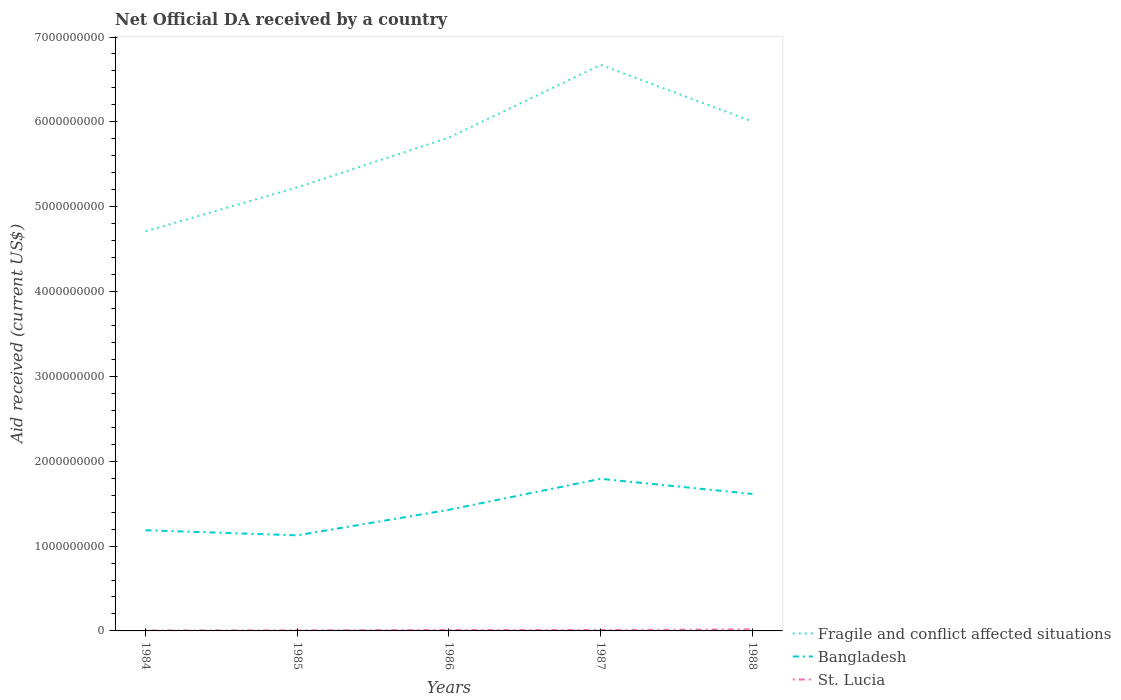How many different coloured lines are there?
Provide a short and direct response. 3. Is the number of lines equal to the number of legend labels?
Ensure brevity in your answer.  Yes. Across all years, what is the maximum net official development assistance aid received in St. Lucia?
Your response must be concise. 5.65e+06. In which year was the net official development assistance aid received in Bangladesh maximum?
Make the answer very short. 1985. What is the total net official development assistance aid received in Bangladesh in the graph?
Offer a terse response. -3.65e+08. What is the difference between the highest and the second highest net official development assistance aid received in St. Lucia?
Your answer should be very brief. 1.23e+07. Is the net official development assistance aid received in Fragile and conflict affected situations strictly greater than the net official development assistance aid received in Bangladesh over the years?
Provide a succinct answer. No. What is the difference between two consecutive major ticks on the Y-axis?
Offer a terse response. 1.00e+09. Does the graph contain grids?
Keep it short and to the point. No. Where does the legend appear in the graph?
Offer a terse response. Bottom right. How many legend labels are there?
Make the answer very short. 3. What is the title of the graph?
Keep it short and to the point. Net Official DA received by a country. What is the label or title of the Y-axis?
Your response must be concise. Aid received (current US$). What is the Aid received (current US$) of Fragile and conflict affected situations in 1984?
Provide a succinct answer. 4.71e+09. What is the Aid received (current US$) in Bangladesh in 1984?
Your answer should be very brief. 1.19e+09. What is the Aid received (current US$) of St. Lucia in 1984?
Make the answer very short. 5.65e+06. What is the Aid received (current US$) in Fragile and conflict affected situations in 1985?
Your answer should be very brief. 5.23e+09. What is the Aid received (current US$) of Bangladesh in 1985?
Your answer should be compact. 1.13e+09. What is the Aid received (current US$) of St. Lucia in 1985?
Your answer should be compact. 6.98e+06. What is the Aid received (current US$) in Fragile and conflict affected situations in 1986?
Provide a succinct answer. 5.81e+09. What is the Aid received (current US$) in Bangladesh in 1986?
Offer a very short reply. 1.43e+09. What is the Aid received (current US$) of St. Lucia in 1986?
Offer a terse response. 1.17e+07. What is the Aid received (current US$) of Fragile and conflict affected situations in 1987?
Provide a short and direct response. 6.67e+09. What is the Aid received (current US$) in Bangladesh in 1987?
Offer a terse response. 1.79e+09. What is the Aid received (current US$) in St. Lucia in 1987?
Give a very brief answer. 1.07e+07. What is the Aid received (current US$) of Fragile and conflict affected situations in 1988?
Offer a very short reply. 6.00e+09. What is the Aid received (current US$) of Bangladesh in 1988?
Offer a very short reply. 1.61e+09. What is the Aid received (current US$) in St. Lucia in 1988?
Your response must be concise. 1.80e+07. Across all years, what is the maximum Aid received (current US$) in Fragile and conflict affected situations?
Ensure brevity in your answer.  6.67e+09. Across all years, what is the maximum Aid received (current US$) in Bangladesh?
Ensure brevity in your answer.  1.79e+09. Across all years, what is the maximum Aid received (current US$) of St. Lucia?
Offer a very short reply. 1.80e+07. Across all years, what is the minimum Aid received (current US$) in Fragile and conflict affected situations?
Provide a short and direct response. 4.71e+09. Across all years, what is the minimum Aid received (current US$) in Bangladesh?
Provide a succinct answer. 1.13e+09. Across all years, what is the minimum Aid received (current US$) in St. Lucia?
Your answer should be very brief. 5.65e+06. What is the total Aid received (current US$) of Fragile and conflict affected situations in the graph?
Your answer should be very brief. 2.84e+1. What is the total Aid received (current US$) in Bangladesh in the graph?
Your answer should be compact. 7.15e+09. What is the total Aid received (current US$) in St. Lucia in the graph?
Ensure brevity in your answer.  5.30e+07. What is the difference between the Aid received (current US$) of Fragile and conflict affected situations in 1984 and that in 1985?
Keep it short and to the point. -5.18e+08. What is the difference between the Aid received (current US$) in Bangladesh in 1984 and that in 1985?
Make the answer very short. 6.03e+07. What is the difference between the Aid received (current US$) of St. Lucia in 1984 and that in 1985?
Give a very brief answer. -1.33e+06. What is the difference between the Aid received (current US$) in Fragile and conflict affected situations in 1984 and that in 1986?
Offer a terse response. -1.11e+09. What is the difference between the Aid received (current US$) in Bangladesh in 1984 and that in 1986?
Offer a terse response. -2.41e+08. What is the difference between the Aid received (current US$) in St. Lucia in 1984 and that in 1986?
Provide a short and direct response. -6.01e+06. What is the difference between the Aid received (current US$) of Fragile and conflict affected situations in 1984 and that in 1987?
Ensure brevity in your answer.  -1.96e+09. What is the difference between the Aid received (current US$) in Bangladesh in 1984 and that in 1987?
Provide a short and direct response. -6.06e+08. What is the difference between the Aid received (current US$) of St. Lucia in 1984 and that in 1987?
Ensure brevity in your answer.  -5.06e+06. What is the difference between the Aid received (current US$) in Fragile and conflict affected situations in 1984 and that in 1988?
Offer a terse response. -1.29e+09. What is the difference between the Aid received (current US$) in Bangladesh in 1984 and that in 1988?
Your response must be concise. -4.28e+08. What is the difference between the Aid received (current US$) of St. Lucia in 1984 and that in 1988?
Provide a short and direct response. -1.23e+07. What is the difference between the Aid received (current US$) in Fragile and conflict affected situations in 1985 and that in 1986?
Offer a very short reply. -5.87e+08. What is the difference between the Aid received (current US$) in Bangladesh in 1985 and that in 1986?
Your answer should be compact. -3.02e+08. What is the difference between the Aid received (current US$) of St. Lucia in 1985 and that in 1986?
Provide a short and direct response. -4.68e+06. What is the difference between the Aid received (current US$) of Fragile and conflict affected situations in 1985 and that in 1987?
Provide a short and direct response. -1.44e+09. What is the difference between the Aid received (current US$) of Bangladesh in 1985 and that in 1987?
Give a very brief answer. -6.66e+08. What is the difference between the Aid received (current US$) of St. Lucia in 1985 and that in 1987?
Your response must be concise. -3.73e+06. What is the difference between the Aid received (current US$) of Fragile and conflict affected situations in 1985 and that in 1988?
Provide a succinct answer. -7.76e+08. What is the difference between the Aid received (current US$) of Bangladesh in 1985 and that in 1988?
Provide a short and direct response. -4.88e+08. What is the difference between the Aid received (current US$) of St. Lucia in 1985 and that in 1988?
Provide a short and direct response. -1.10e+07. What is the difference between the Aid received (current US$) of Fragile and conflict affected situations in 1986 and that in 1987?
Offer a very short reply. -8.57e+08. What is the difference between the Aid received (current US$) of Bangladesh in 1986 and that in 1987?
Make the answer very short. -3.65e+08. What is the difference between the Aid received (current US$) of St. Lucia in 1986 and that in 1987?
Your answer should be very brief. 9.50e+05. What is the difference between the Aid received (current US$) of Fragile and conflict affected situations in 1986 and that in 1988?
Offer a very short reply. -1.89e+08. What is the difference between the Aid received (current US$) in Bangladesh in 1986 and that in 1988?
Provide a succinct answer. -1.86e+08. What is the difference between the Aid received (current US$) of St. Lucia in 1986 and that in 1988?
Your answer should be very brief. -6.30e+06. What is the difference between the Aid received (current US$) of Fragile and conflict affected situations in 1987 and that in 1988?
Your answer should be very brief. 6.68e+08. What is the difference between the Aid received (current US$) of Bangladesh in 1987 and that in 1988?
Offer a very short reply. 1.78e+08. What is the difference between the Aid received (current US$) of St. Lucia in 1987 and that in 1988?
Give a very brief answer. -7.25e+06. What is the difference between the Aid received (current US$) in Fragile and conflict affected situations in 1984 and the Aid received (current US$) in Bangladesh in 1985?
Offer a terse response. 3.58e+09. What is the difference between the Aid received (current US$) of Fragile and conflict affected situations in 1984 and the Aid received (current US$) of St. Lucia in 1985?
Ensure brevity in your answer.  4.70e+09. What is the difference between the Aid received (current US$) in Bangladesh in 1984 and the Aid received (current US$) in St. Lucia in 1985?
Your response must be concise. 1.18e+09. What is the difference between the Aid received (current US$) in Fragile and conflict affected situations in 1984 and the Aid received (current US$) in Bangladesh in 1986?
Your answer should be very brief. 3.28e+09. What is the difference between the Aid received (current US$) of Fragile and conflict affected situations in 1984 and the Aid received (current US$) of St. Lucia in 1986?
Offer a very short reply. 4.70e+09. What is the difference between the Aid received (current US$) of Bangladesh in 1984 and the Aid received (current US$) of St. Lucia in 1986?
Your answer should be very brief. 1.18e+09. What is the difference between the Aid received (current US$) in Fragile and conflict affected situations in 1984 and the Aid received (current US$) in Bangladesh in 1987?
Provide a succinct answer. 2.92e+09. What is the difference between the Aid received (current US$) in Fragile and conflict affected situations in 1984 and the Aid received (current US$) in St. Lucia in 1987?
Offer a terse response. 4.70e+09. What is the difference between the Aid received (current US$) of Bangladesh in 1984 and the Aid received (current US$) of St. Lucia in 1987?
Your response must be concise. 1.18e+09. What is the difference between the Aid received (current US$) in Fragile and conflict affected situations in 1984 and the Aid received (current US$) in Bangladesh in 1988?
Give a very brief answer. 3.10e+09. What is the difference between the Aid received (current US$) in Fragile and conflict affected situations in 1984 and the Aid received (current US$) in St. Lucia in 1988?
Your answer should be compact. 4.69e+09. What is the difference between the Aid received (current US$) in Bangladesh in 1984 and the Aid received (current US$) in St. Lucia in 1988?
Provide a short and direct response. 1.17e+09. What is the difference between the Aid received (current US$) in Fragile and conflict affected situations in 1985 and the Aid received (current US$) in Bangladesh in 1986?
Make the answer very short. 3.80e+09. What is the difference between the Aid received (current US$) of Fragile and conflict affected situations in 1985 and the Aid received (current US$) of St. Lucia in 1986?
Provide a succinct answer. 5.22e+09. What is the difference between the Aid received (current US$) of Bangladesh in 1985 and the Aid received (current US$) of St. Lucia in 1986?
Make the answer very short. 1.11e+09. What is the difference between the Aid received (current US$) in Fragile and conflict affected situations in 1985 and the Aid received (current US$) in Bangladesh in 1987?
Make the answer very short. 3.44e+09. What is the difference between the Aid received (current US$) of Fragile and conflict affected situations in 1985 and the Aid received (current US$) of St. Lucia in 1987?
Provide a succinct answer. 5.22e+09. What is the difference between the Aid received (current US$) of Bangladesh in 1985 and the Aid received (current US$) of St. Lucia in 1987?
Your answer should be very brief. 1.12e+09. What is the difference between the Aid received (current US$) in Fragile and conflict affected situations in 1985 and the Aid received (current US$) in Bangladesh in 1988?
Your response must be concise. 3.61e+09. What is the difference between the Aid received (current US$) in Fragile and conflict affected situations in 1985 and the Aid received (current US$) in St. Lucia in 1988?
Provide a succinct answer. 5.21e+09. What is the difference between the Aid received (current US$) in Bangladesh in 1985 and the Aid received (current US$) in St. Lucia in 1988?
Ensure brevity in your answer.  1.11e+09. What is the difference between the Aid received (current US$) of Fragile and conflict affected situations in 1986 and the Aid received (current US$) of Bangladesh in 1987?
Your answer should be compact. 4.02e+09. What is the difference between the Aid received (current US$) of Fragile and conflict affected situations in 1986 and the Aid received (current US$) of St. Lucia in 1987?
Your answer should be compact. 5.80e+09. What is the difference between the Aid received (current US$) in Bangladesh in 1986 and the Aid received (current US$) in St. Lucia in 1987?
Provide a short and direct response. 1.42e+09. What is the difference between the Aid received (current US$) in Fragile and conflict affected situations in 1986 and the Aid received (current US$) in Bangladesh in 1988?
Your answer should be compact. 4.20e+09. What is the difference between the Aid received (current US$) of Fragile and conflict affected situations in 1986 and the Aid received (current US$) of St. Lucia in 1988?
Your answer should be very brief. 5.80e+09. What is the difference between the Aid received (current US$) of Bangladesh in 1986 and the Aid received (current US$) of St. Lucia in 1988?
Make the answer very short. 1.41e+09. What is the difference between the Aid received (current US$) in Fragile and conflict affected situations in 1987 and the Aid received (current US$) in Bangladesh in 1988?
Provide a short and direct response. 5.06e+09. What is the difference between the Aid received (current US$) in Fragile and conflict affected situations in 1987 and the Aid received (current US$) in St. Lucia in 1988?
Your response must be concise. 6.65e+09. What is the difference between the Aid received (current US$) in Bangladesh in 1987 and the Aid received (current US$) in St. Lucia in 1988?
Your answer should be compact. 1.77e+09. What is the average Aid received (current US$) in Fragile and conflict affected situations per year?
Make the answer very short. 5.69e+09. What is the average Aid received (current US$) of Bangladesh per year?
Your answer should be very brief. 1.43e+09. What is the average Aid received (current US$) in St. Lucia per year?
Provide a succinct answer. 1.06e+07. In the year 1984, what is the difference between the Aid received (current US$) in Fragile and conflict affected situations and Aid received (current US$) in Bangladesh?
Provide a short and direct response. 3.52e+09. In the year 1984, what is the difference between the Aid received (current US$) in Fragile and conflict affected situations and Aid received (current US$) in St. Lucia?
Make the answer very short. 4.70e+09. In the year 1984, what is the difference between the Aid received (current US$) in Bangladesh and Aid received (current US$) in St. Lucia?
Provide a succinct answer. 1.18e+09. In the year 1985, what is the difference between the Aid received (current US$) in Fragile and conflict affected situations and Aid received (current US$) in Bangladesh?
Offer a very short reply. 4.10e+09. In the year 1985, what is the difference between the Aid received (current US$) in Fragile and conflict affected situations and Aid received (current US$) in St. Lucia?
Offer a terse response. 5.22e+09. In the year 1985, what is the difference between the Aid received (current US$) of Bangladesh and Aid received (current US$) of St. Lucia?
Ensure brevity in your answer.  1.12e+09. In the year 1986, what is the difference between the Aid received (current US$) of Fragile and conflict affected situations and Aid received (current US$) of Bangladesh?
Ensure brevity in your answer.  4.39e+09. In the year 1986, what is the difference between the Aid received (current US$) of Fragile and conflict affected situations and Aid received (current US$) of St. Lucia?
Your answer should be compact. 5.80e+09. In the year 1986, what is the difference between the Aid received (current US$) in Bangladesh and Aid received (current US$) in St. Lucia?
Make the answer very short. 1.42e+09. In the year 1987, what is the difference between the Aid received (current US$) in Fragile and conflict affected situations and Aid received (current US$) in Bangladesh?
Offer a very short reply. 4.88e+09. In the year 1987, what is the difference between the Aid received (current US$) in Fragile and conflict affected situations and Aid received (current US$) in St. Lucia?
Provide a short and direct response. 6.66e+09. In the year 1987, what is the difference between the Aid received (current US$) of Bangladesh and Aid received (current US$) of St. Lucia?
Offer a very short reply. 1.78e+09. In the year 1988, what is the difference between the Aid received (current US$) in Fragile and conflict affected situations and Aid received (current US$) in Bangladesh?
Make the answer very short. 4.39e+09. In the year 1988, what is the difference between the Aid received (current US$) of Fragile and conflict affected situations and Aid received (current US$) of St. Lucia?
Your answer should be very brief. 5.99e+09. In the year 1988, what is the difference between the Aid received (current US$) of Bangladesh and Aid received (current US$) of St. Lucia?
Your answer should be compact. 1.60e+09. What is the ratio of the Aid received (current US$) in Fragile and conflict affected situations in 1984 to that in 1985?
Offer a terse response. 0.9. What is the ratio of the Aid received (current US$) of Bangladesh in 1984 to that in 1985?
Give a very brief answer. 1.05. What is the ratio of the Aid received (current US$) in St. Lucia in 1984 to that in 1985?
Ensure brevity in your answer.  0.81. What is the ratio of the Aid received (current US$) of Fragile and conflict affected situations in 1984 to that in 1986?
Ensure brevity in your answer.  0.81. What is the ratio of the Aid received (current US$) of Bangladesh in 1984 to that in 1986?
Offer a very short reply. 0.83. What is the ratio of the Aid received (current US$) of St. Lucia in 1984 to that in 1986?
Offer a terse response. 0.48. What is the ratio of the Aid received (current US$) in Fragile and conflict affected situations in 1984 to that in 1987?
Your response must be concise. 0.71. What is the ratio of the Aid received (current US$) of Bangladesh in 1984 to that in 1987?
Ensure brevity in your answer.  0.66. What is the ratio of the Aid received (current US$) of St. Lucia in 1984 to that in 1987?
Make the answer very short. 0.53. What is the ratio of the Aid received (current US$) in Fragile and conflict affected situations in 1984 to that in 1988?
Make the answer very short. 0.78. What is the ratio of the Aid received (current US$) of Bangladesh in 1984 to that in 1988?
Provide a short and direct response. 0.74. What is the ratio of the Aid received (current US$) in St. Lucia in 1984 to that in 1988?
Make the answer very short. 0.31. What is the ratio of the Aid received (current US$) in Fragile and conflict affected situations in 1985 to that in 1986?
Offer a very short reply. 0.9. What is the ratio of the Aid received (current US$) of Bangladesh in 1985 to that in 1986?
Keep it short and to the point. 0.79. What is the ratio of the Aid received (current US$) of St. Lucia in 1985 to that in 1986?
Ensure brevity in your answer.  0.6. What is the ratio of the Aid received (current US$) of Fragile and conflict affected situations in 1985 to that in 1987?
Make the answer very short. 0.78. What is the ratio of the Aid received (current US$) of Bangladesh in 1985 to that in 1987?
Offer a very short reply. 0.63. What is the ratio of the Aid received (current US$) in St. Lucia in 1985 to that in 1987?
Keep it short and to the point. 0.65. What is the ratio of the Aid received (current US$) of Fragile and conflict affected situations in 1985 to that in 1988?
Your response must be concise. 0.87. What is the ratio of the Aid received (current US$) in Bangladesh in 1985 to that in 1988?
Ensure brevity in your answer.  0.7. What is the ratio of the Aid received (current US$) of St. Lucia in 1985 to that in 1988?
Make the answer very short. 0.39. What is the ratio of the Aid received (current US$) in Fragile and conflict affected situations in 1986 to that in 1987?
Your answer should be compact. 0.87. What is the ratio of the Aid received (current US$) in Bangladesh in 1986 to that in 1987?
Make the answer very short. 0.8. What is the ratio of the Aid received (current US$) of St. Lucia in 1986 to that in 1987?
Keep it short and to the point. 1.09. What is the ratio of the Aid received (current US$) in Fragile and conflict affected situations in 1986 to that in 1988?
Ensure brevity in your answer.  0.97. What is the ratio of the Aid received (current US$) in Bangladesh in 1986 to that in 1988?
Make the answer very short. 0.88. What is the ratio of the Aid received (current US$) in St. Lucia in 1986 to that in 1988?
Ensure brevity in your answer.  0.65. What is the ratio of the Aid received (current US$) of Fragile and conflict affected situations in 1987 to that in 1988?
Give a very brief answer. 1.11. What is the ratio of the Aid received (current US$) of Bangladesh in 1987 to that in 1988?
Give a very brief answer. 1.11. What is the ratio of the Aid received (current US$) in St. Lucia in 1987 to that in 1988?
Your response must be concise. 0.6. What is the difference between the highest and the second highest Aid received (current US$) in Fragile and conflict affected situations?
Make the answer very short. 6.68e+08. What is the difference between the highest and the second highest Aid received (current US$) in Bangladesh?
Ensure brevity in your answer.  1.78e+08. What is the difference between the highest and the second highest Aid received (current US$) of St. Lucia?
Your response must be concise. 6.30e+06. What is the difference between the highest and the lowest Aid received (current US$) in Fragile and conflict affected situations?
Give a very brief answer. 1.96e+09. What is the difference between the highest and the lowest Aid received (current US$) of Bangladesh?
Ensure brevity in your answer.  6.66e+08. What is the difference between the highest and the lowest Aid received (current US$) in St. Lucia?
Offer a very short reply. 1.23e+07. 